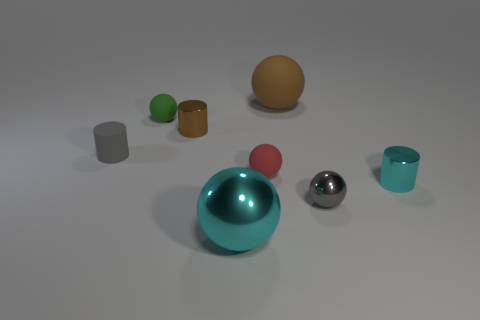There is a tiny object in front of the small cyan cylinder that is right of the gray matte cylinder; what number of tiny cyan shiny cylinders are to the left of it?
Offer a very short reply. 0. How many gray objects are either small shiny balls or big shiny spheres?
Offer a terse response. 1. What color is the other tiny sphere that is made of the same material as the green sphere?
Provide a short and direct response. Red. Are there any other things that are the same size as the gray metal sphere?
Your response must be concise. Yes. What number of tiny objects are cyan shiny objects or gray objects?
Offer a very short reply. 3. Is the number of tiny red rubber objects less than the number of brown objects?
Offer a very short reply. Yes. The other small rubber object that is the same shape as the small red rubber object is what color?
Give a very brief answer. Green. Is there anything else that has the same shape as the tiny green object?
Ensure brevity in your answer.  Yes. Are there more large yellow cylinders than big spheres?
Offer a terse response. No. What number of other things are made of the same material as the small gray cylinder?
Offer a very short reply. 3. 